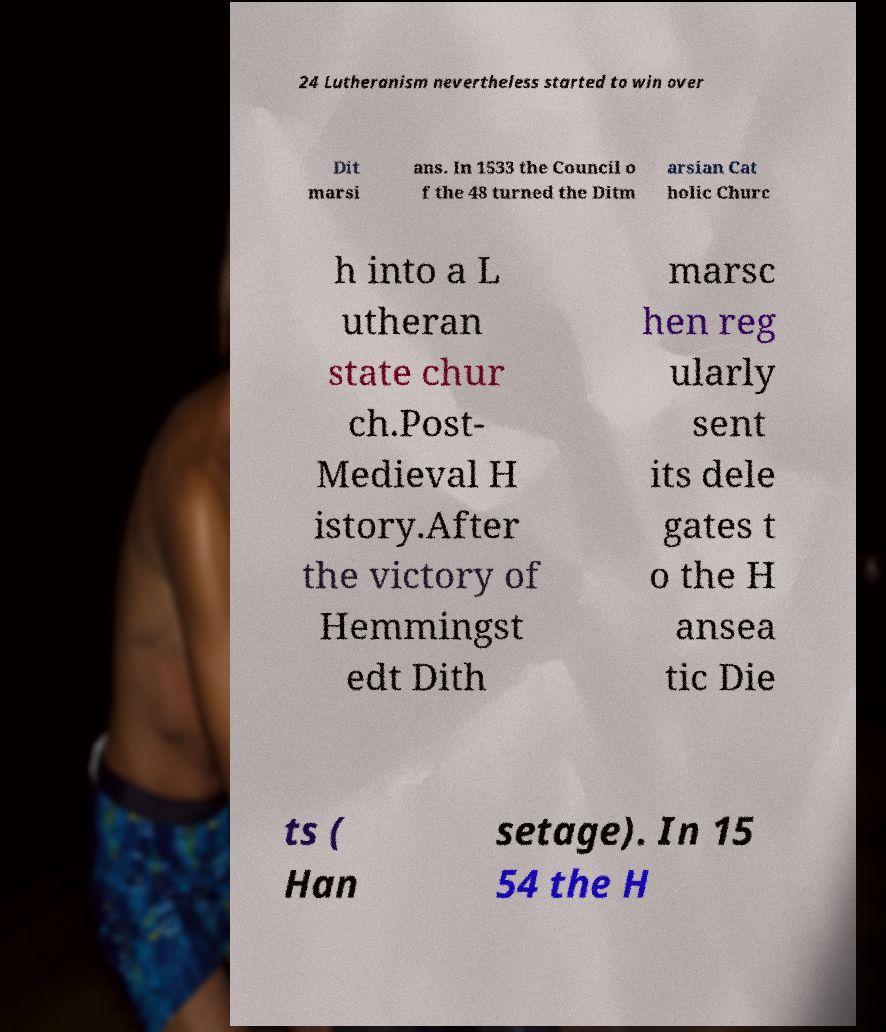Could you extract and type out the text from this image? 24 Lutheranism nevertheless started to win over Dit marsi ans. In 1533 the Council o f the 48 turned the Ditm arsian Cat holic Churc h into a L utheran state chur ch.Post- Medieval H istory.After the victory of Hemmingst edt Dith marsc hen reg ularly sent its dele gates t o the H ansea tic Die ts ( Han setage). In 15 54 the H 